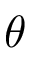Convert formula to latex. <formula><loc_0><loc_0><loc_500><loc_500>\theta</formula> 